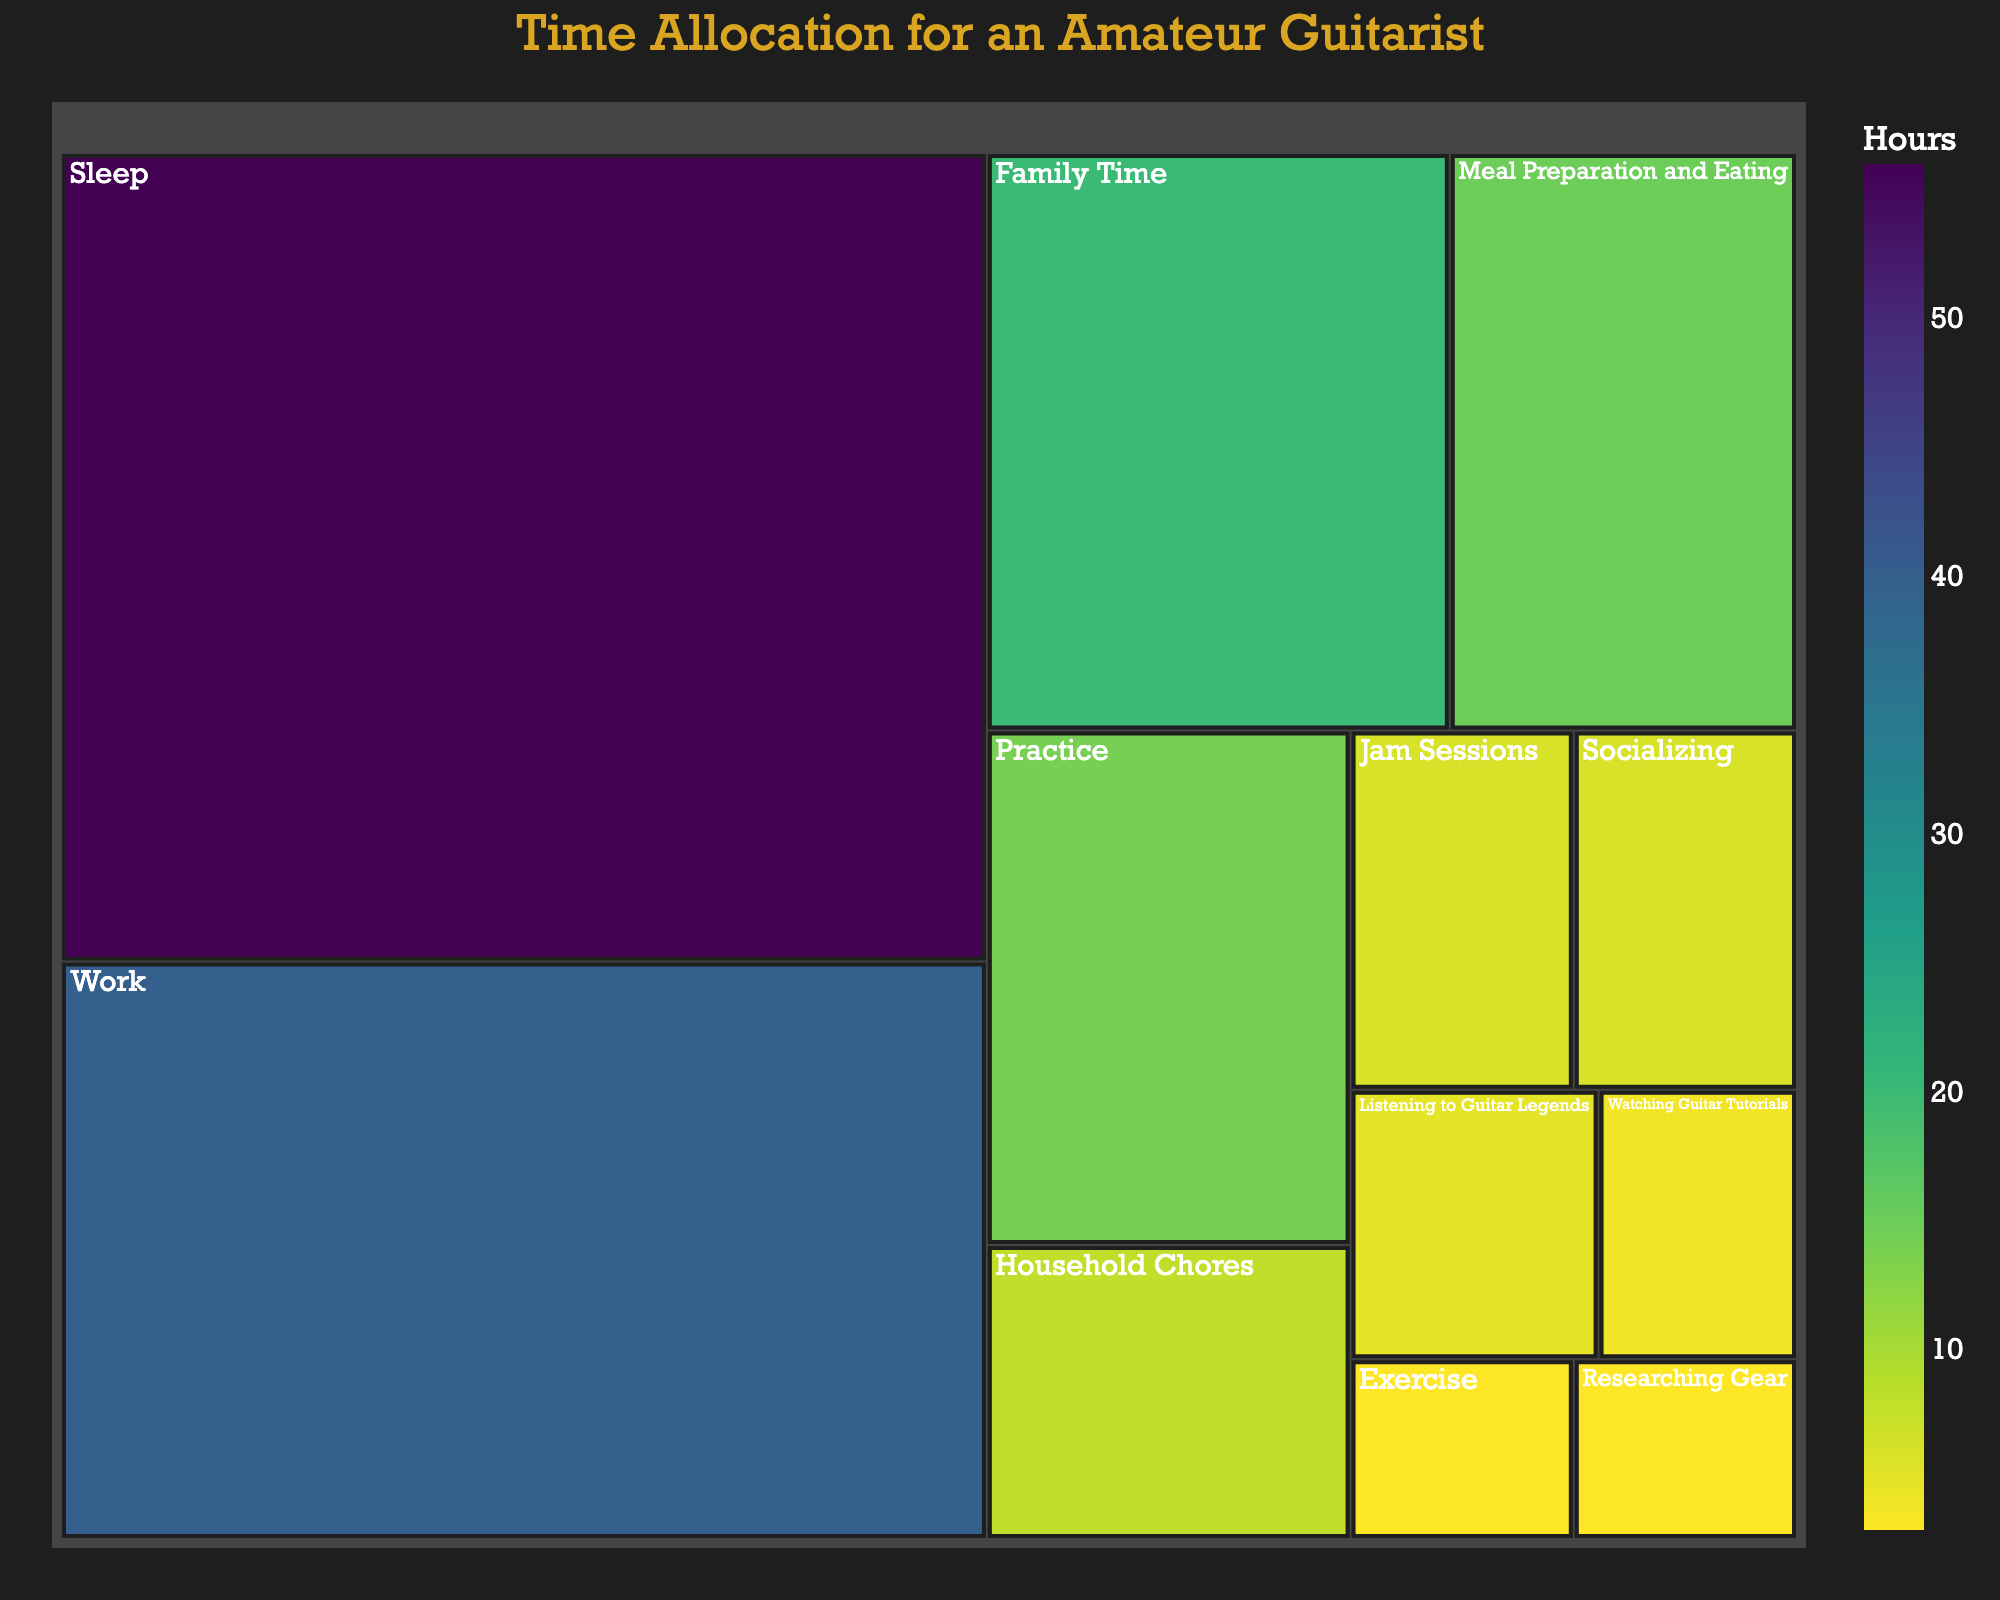What's the title of the treemap? Look for the text at the top center of the treemap.
Answer: Time Allocation for an Amateur Guitarist What activity takes up the most hours? Identify the largest section in the treemap, which usually represents the activity with the highest value.
Answer: Sleep How many hours are spent on meal preparation and eating? Locate the section labeled "Meal Preparation and Eating" and check the hover data for the number of hours.
Answer: 15 What is the total number of hours spent on Socializing and Jam Sessions combined? Find the sections for "Socializing" and "Jam Sessions" and add their hours together: 6 (Socializing) + 6 (Jam Sessions).
Answer: 12 Which activity takes the least amount of time? Identify the smallest section in the treemap.
Answer: Researching Gear How much more time is spent on Work compared to Practice? Subtract the hours spent on Practice from the hours spent on Work: 40 (Work) - 14 (Practice).
Answer: 26 What are the activities that have an equal amount of time allocation? Compare the sizes and hover data for the sections.
Answer: Jam Sessions and Socializing How many hours in total are spent on activities related to guitar (Practice, Jam Sessions, Listening to Guitar Legends, Researching Gear, Watching Guitar Tutorials)? Sum the hours: 14 (Practice) + 6 (Jam Sessions) + 5 (Listening to Guitar Legends) + 3 (Researching Gear) + 4 (Watching Guitar Tutorials).
Answer: 32 What is the color scheme used in the treemap? Examine the color variation in the sections and hover data, noting the gradient or sequence.
Answer: Viridis Which takes up more hours, Family Time or Work and Household Chores combined? Add the hours of Work and Household Chores and compare with Family Time: 40 (Work) + 8 (Household Chores) = 48. Compare 48 with 20 (Family Time).
Answer: Work and Household Chores 